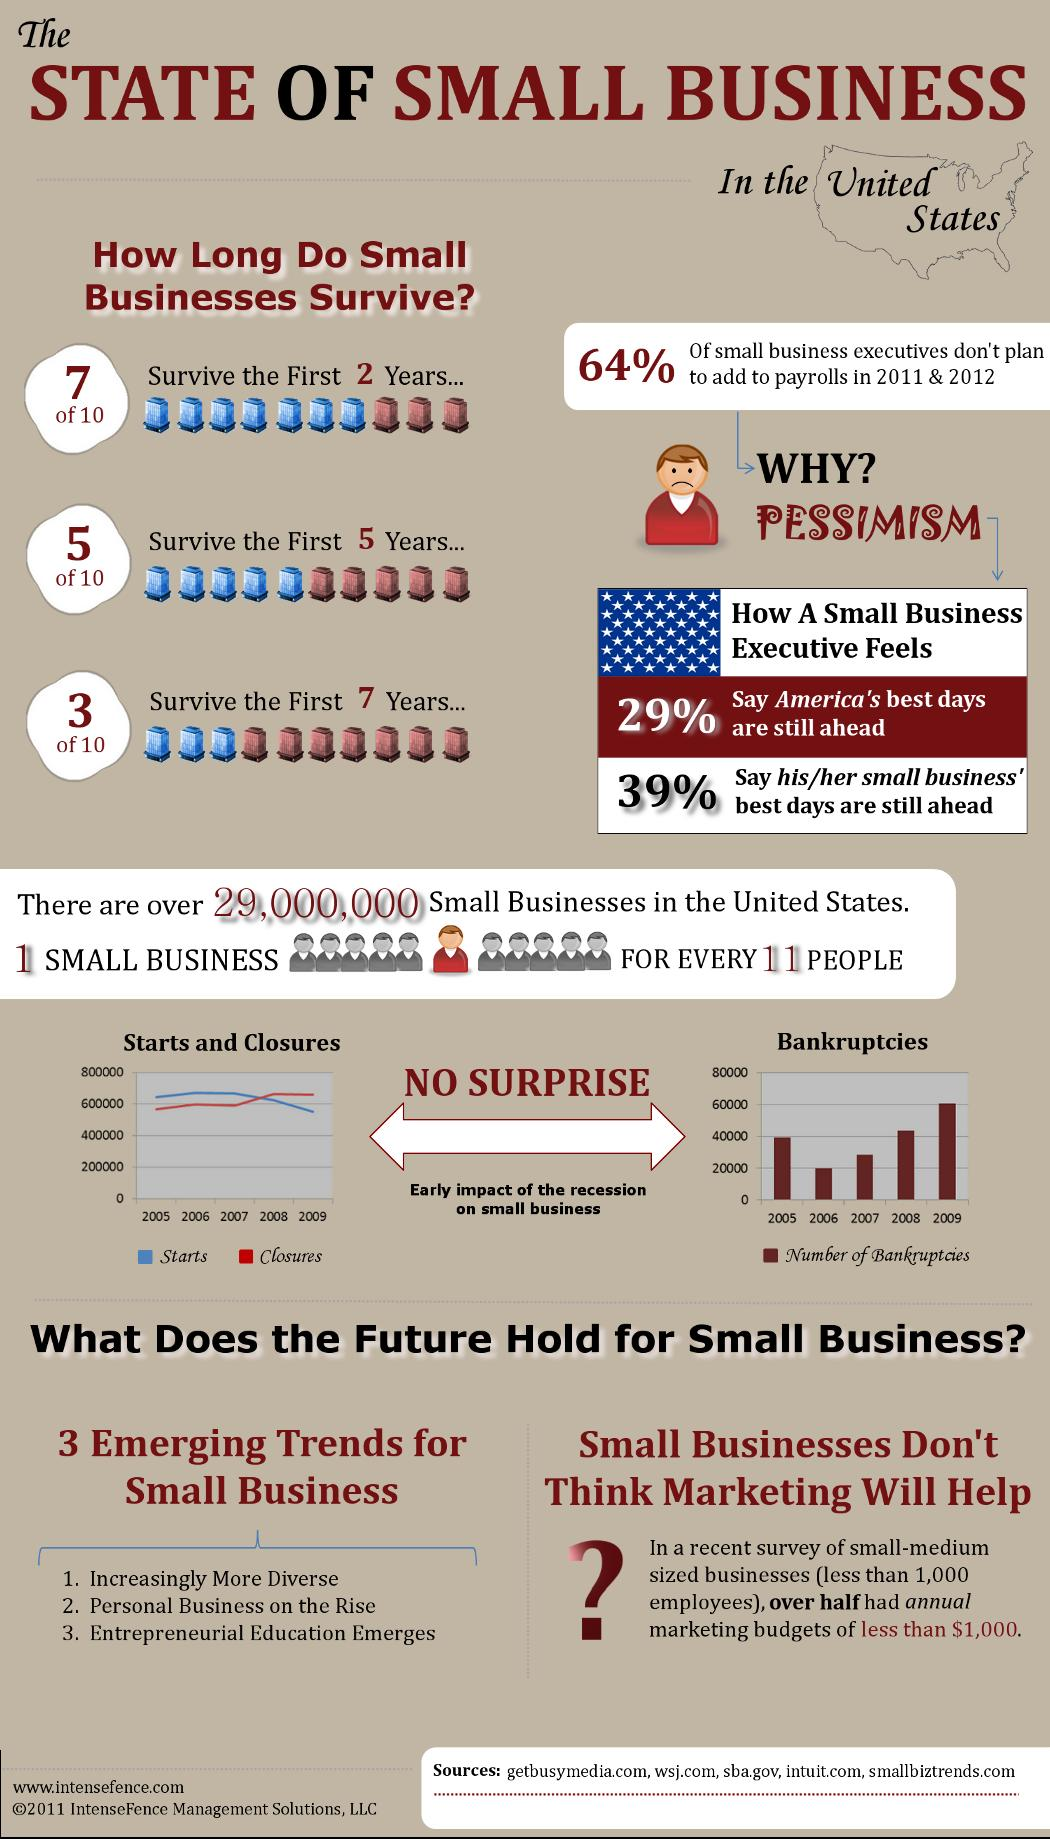Outline some significant characteristics in this image. According to recent statistics, over half of small businesses in the United States are able to survive the first five years of operation. There were approximately 3,000 bankruptcies in 2007. A recent study found that only 70% of small businesses survive beyond the first two years. The number of bankruptcies was the second highest in 2008. According to a survey of small business executives, 36% plan to increase their payrolls in 2011 and 2012. 